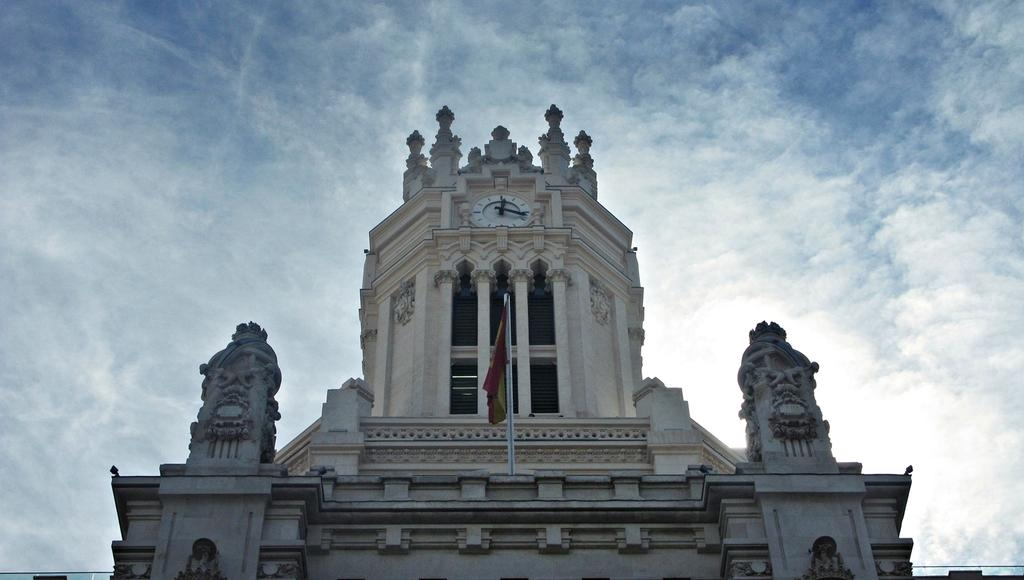What type of structure is present in the image? There is a building in the image. What object can be seen on the building? There is a clock on the building. What other object is present in the image? There is a flag in the image. What can be seen in the background of the image? The sky is visible in the background of the image. What is the condition of the sky in the image? Clouds are present in the sky. What type of toy can be seen playing in the dirt in the image? There is no toy or dirt present in the image; it features a building, a clock, a flag, and a cloudy sky. 